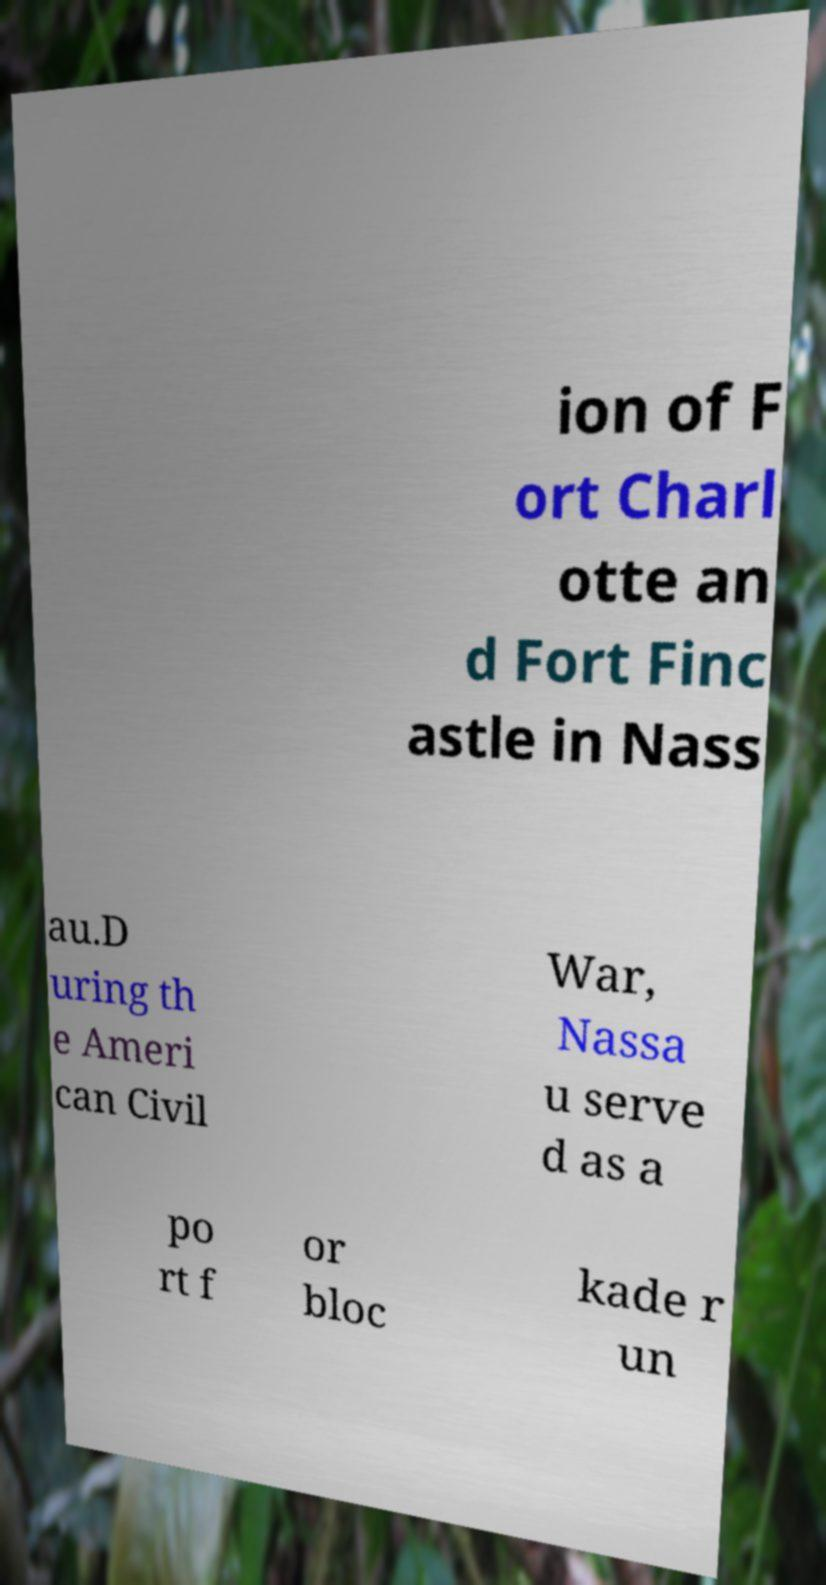What messages or text are displayed in this image? I need them in a readable, typed format. ion of F ort Charl otte an d Fort Finc astle in Nass au.D uring th e Ameri can Civil War, Nassa u serve d as a po rt f or bloc kade r un 